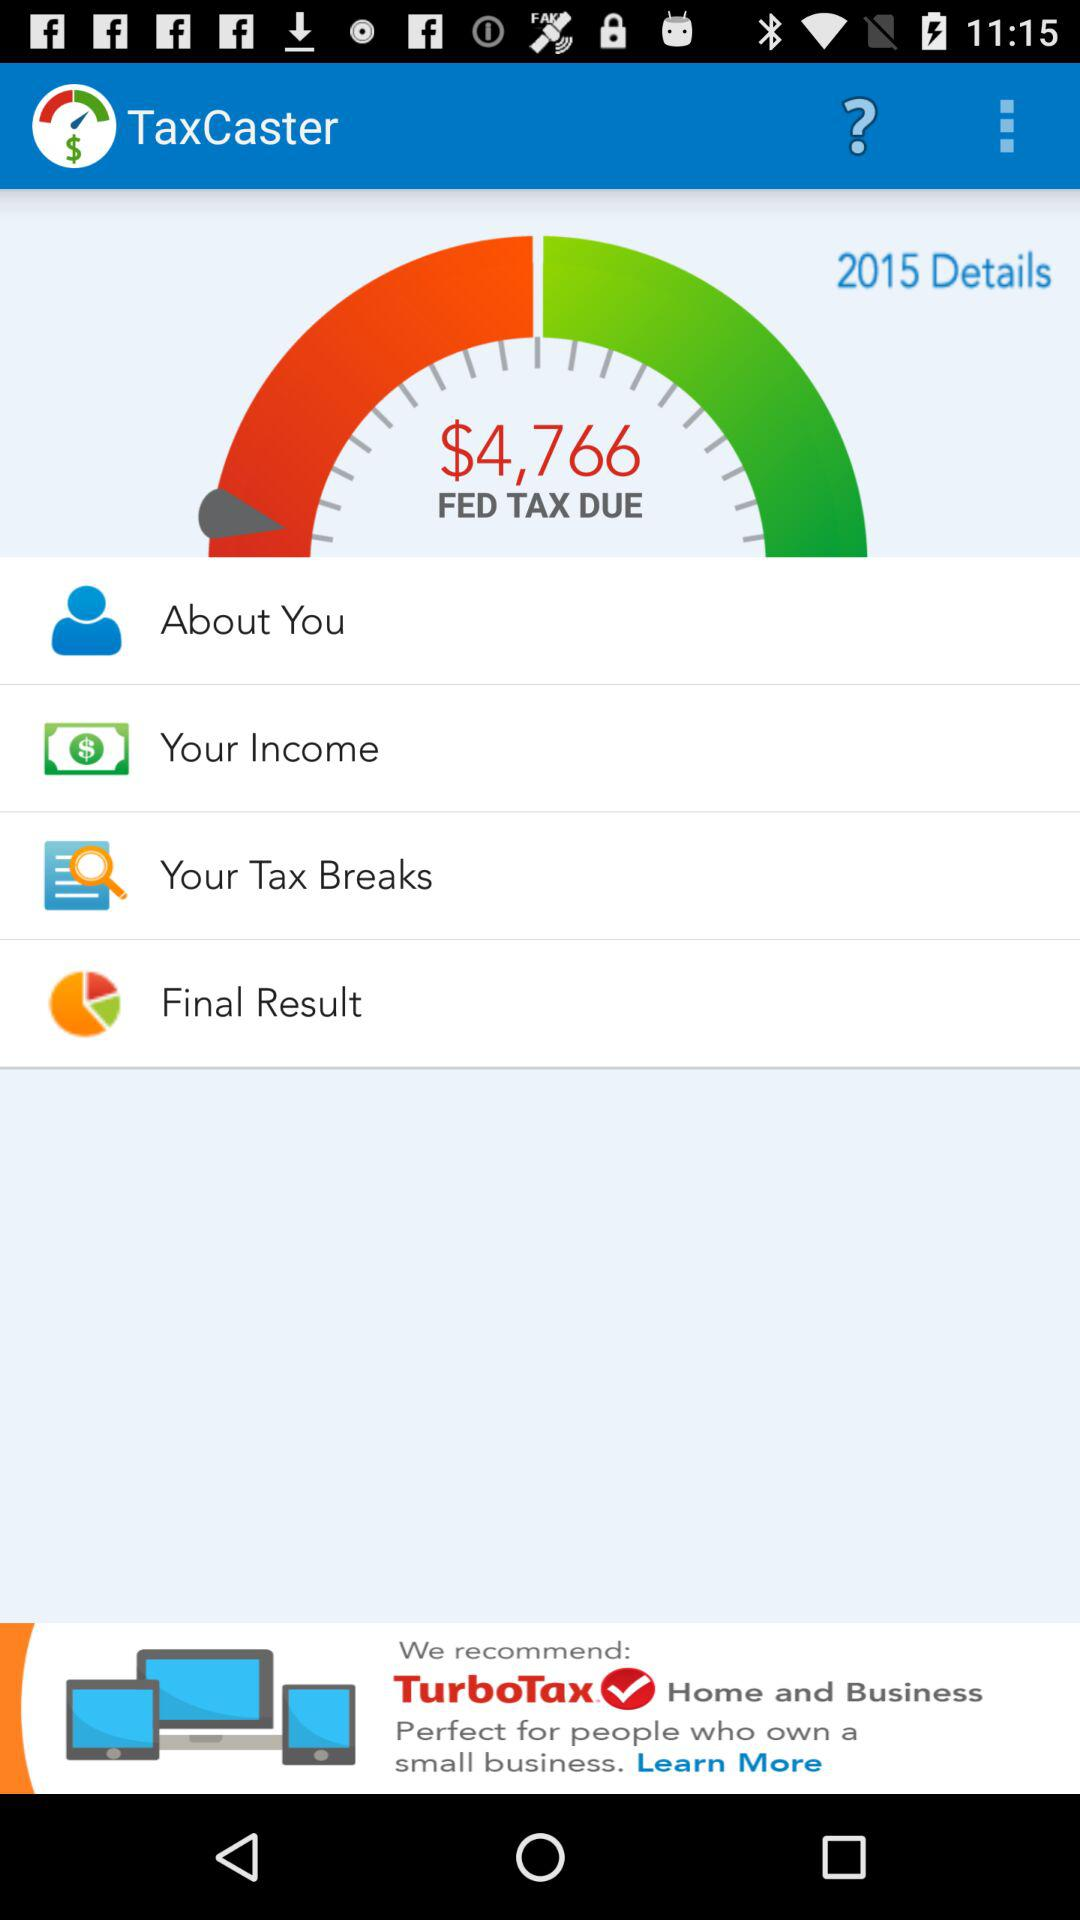How much is the tax due?
Answer the question using a single word or phrase. $4,766 